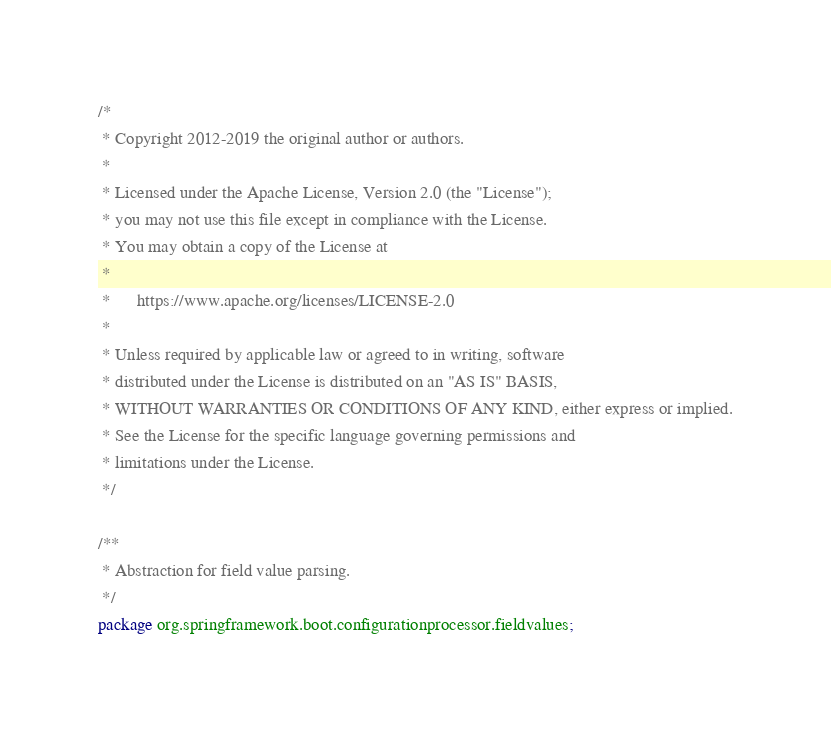<code> <loc_0><loc_0><loc_500><loc_500><_Java_>/*
 * Copyright 2012-2019 the original author or authors.
 *
 * Licensed under the Apache License, Version 2.0 (the "License");
 * you may not use this file except in compliance with the License.
 * You may obtain a copy of the License at
 *
 *      https://www.apache.org/licenses/LICENSE-2.0
 *
 * Unless required by applicable law or agreed to in writing, software
 * distributed under the License is distributed on an "AS IS" BASIS,
 * WITHOUT WARRANTIES OR CONDITIONS OF ANY KIND, either express or implied.
 * See the License for the specific language governing permissions and
 * limitations under the License.
 */

/**
 * Abstraction for field value parsing.
 */
package org.springframework.boot.configurationprocessor.fieldvalues;
</code> 